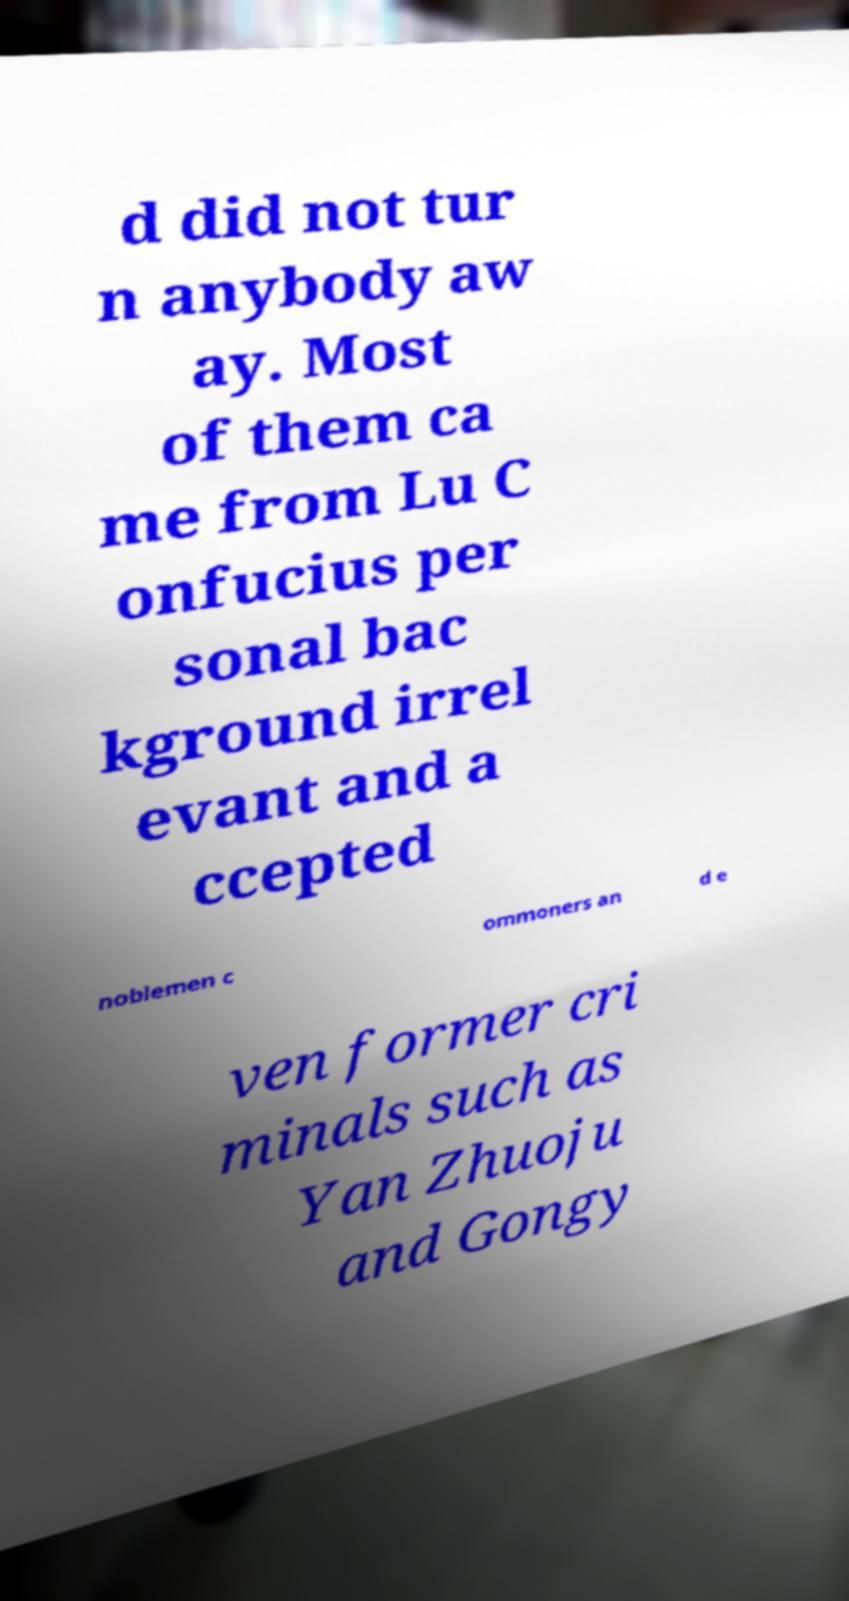There's text embedded in this image that I need extracted. Can you transcribe it verbatim? d did not tur n anybody aw ay. Most of them ca me from Lu C onfucius per sonal bac kground irrel evant and a ccepted noblemen c ommoners an d e ven former cri minals such as Yan Zhuoju and Gongy 